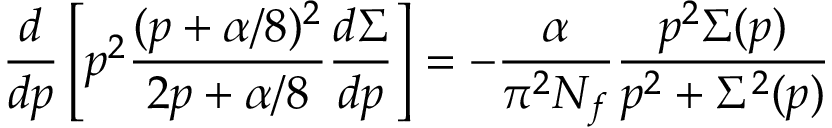Convert formula to latex. <formula><loc_0><loc_0><loc_500><loc_500>{ \frac { d } { d p } } \left [ p ^ { 2 } \frac { ( p + \alpha / 8 ) ^ { 2 } } { 2 p + \alpha / 8 } \frac { d \Sigma } { d p } \right ] = - \frac { \alpha } { \pi ^ { 2 } N _ { f } } \frac { p ^ { 2 } \Sigma ( p ) } { p ^ { 2 } + \Sigma ^ { 2 } ( p ) }</formula> 